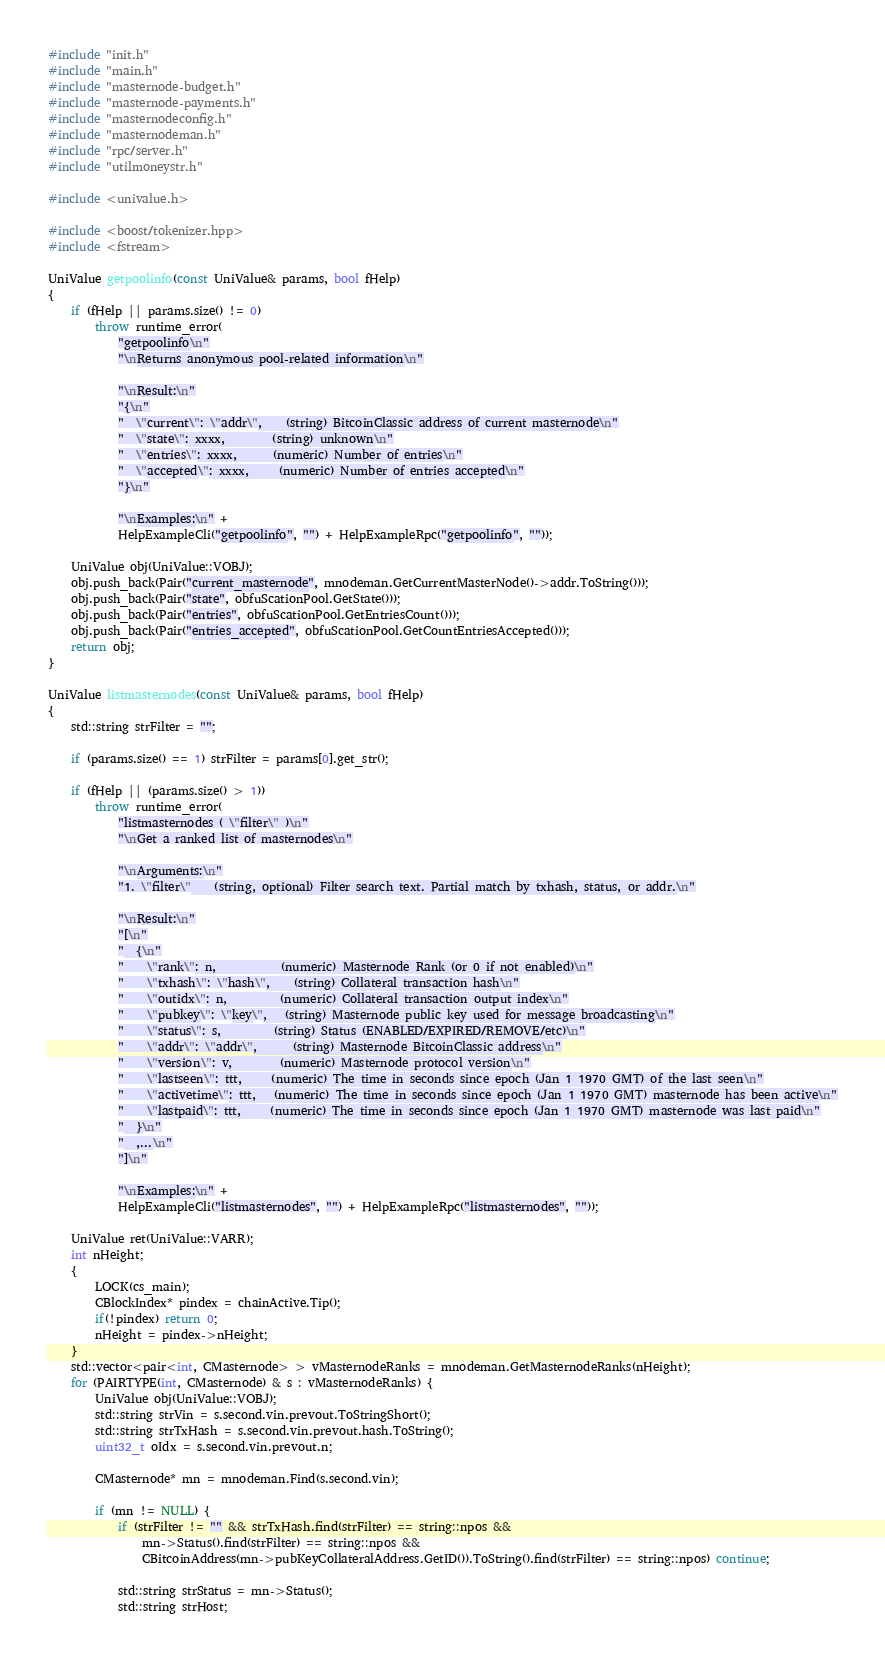Convert code to text. <code><loc_0><loc_0><loc_500><loc_500><_C++_>#include "init.h"
#include "main.h"
#include "masternode-budget.h"
#include "masternode-payments.h"
#include "masternodeconfig.h"
#include "masternodeman.h"
#include "rpc/server.h"
#include "utilmoneystr.h"

#include <univalue.h>

#include <boost/tokenizer.hpp>
#include <fstream>

UniValue getpoolinfo(const UniValue& params, bool fHelp)
{
    if (fHelp || params.size() != 0)
        throw runtime_error(
            "getpoolinfo\n"
            "\nReturns anonymous pool-related information\n"

            "\nResult:\n"
            "{\n"
            "  \"current\": \"addr\",    (string) BitcoinClassic address of current masternode\n"
            "  \"state\": xxxx,        (string) unknown\n"
            "  \"entries\": xxxx,      (numeric) Number of entries\n"
            "  \"accepted\": xxxx,     (numeric) Number of entries accepted\n"
            "}\n"

            "\nExamples:\n" +
            HelpExampleCli("getpoolinfo", "") + HelpExampleRpc("getpoolinfo", ""));

    UniValue obj(UniValue::VOBJ);
    obj.push_back(Pair("current_masternode", mnodeman.GetCurrentMasterNode()->addr.ToString()));
    obj.push_back(Pair("state", obfuScationPool.GetState()));
    obj.push_back(Pair("entries", obfuScationPool.GetEntriesCount()));
    obj.push_back(Pair("entries_accepted", obfuScationPool.GetCountEntriesAccepted()));
    return obj;
}

UniValue listmasternodes(const UniValue& params, bool fHelp)
{
    std::string strFilter = "";

    if (params.size() == 1) strFilter = params[0].get_str();

    if (fHelp || (params.size() > 1))
        throw runtime_error(
            "listmasternodes ( \"filter\" )\n"
            "\nGet a ranked list of masternodes\n"

            "\nArguments:\n"
            "1. \"filter\"    (string, optional) Filter search text. Partial match by txhash, status, or addr.\n"

            "\nResult:\n"
            "[\n"
            "  {\n"
            "    \"rank\": n,           (numeric) Masternode Rank (or 0 if not enabled)\n"
            "    \"txhash\": \"hash\",    (string) Collateral transaction hash\n"
            "    \"outidx\": n,         (numeric) Collateral transaction output index\n"
            "    \"pubkey\": \"key\",   (string) Masternode public key used for message broadcasting\n"
            "    \"status\": s,         (string) Status (ENABLED/EXPIRED/REMOVE/etc)\n"
            "    \"addr\": \"addr\",      (string) Masternode BitcoinClassic address\n"
            "    \"version\": v,        (numeric) Masternode protocol version\n"
            "    \"lastseen\": ttt,     (numeric) The time in seconds since epoch (Jan 1 1970 GMT) of the last seen\n"
            "    \"activetime\": ttt,   (numeric) The time in seconds since epoch (Jan 1 1970 GMT) masternode has been active\n"
            "    \"lastpaid\": ttt,     (numeric) The time in seconds since epoch (Jan 1 1970 GMT) masternode was last paid\n"
            "  }\n"
            "  ,...\n"
            "]\n"

            "\nExamples:\n" +
            HelpExampleCli("listmasternodes", "") + HelpExampleRpc("listmasternodes", ""));

    UniValue ret(UniValue::VARR);
    int nHeight;
    {
        LOCK(cs_main);
        CBlockIndex* pindex = chainActive.Tip();
        if(!pindex) return 0;
        nHeight = pindex->nHeight;
    }
    std::vector<pair<int, CMasternode> > vMasternodeRanks = mnodeman.GetMasternodeRanks(nHeight);
    for (PAIRTYPE(int, CMasternode) & s : vMasternodeRanks) {
        UniValue obj(UniValue::VOBJ);
        std::string strVin = s.second.vin.prevout.ToStringShort();
        std::string strTxHash = s.second.vin.prevout.hash.ToString();
        uint32_t oIdx = s.second.vin.prevout.n;

        CMasternode* mn = mnodeman.Find(s.second.vin);

        if (mn != NULL) {
            if (strFilter != "" && strTxHash.find(strFilter) == string::npos &&
                mn->Status().find(strFilter) == string::npos &&
                CBitcoinAddress(mn->pubKeyCollateralAddress.GetID()).ToString().find(strFilter) == string::npos) continue;

            std::string strStatus = mn->Status();
            std::string strHost;</code> 